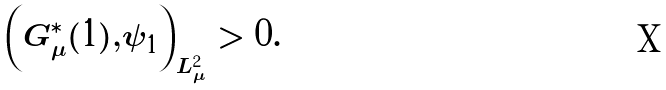Convert formula to latex. <formula><loc_0><loc_0><loc_500><loc_500>\left ( G _ { \mu } ^ { \ast } ( 1 ) , \psi _ { 1 } \right ) _ { L _ { \mu } ^ { 2 } } > 0 .</formula> 